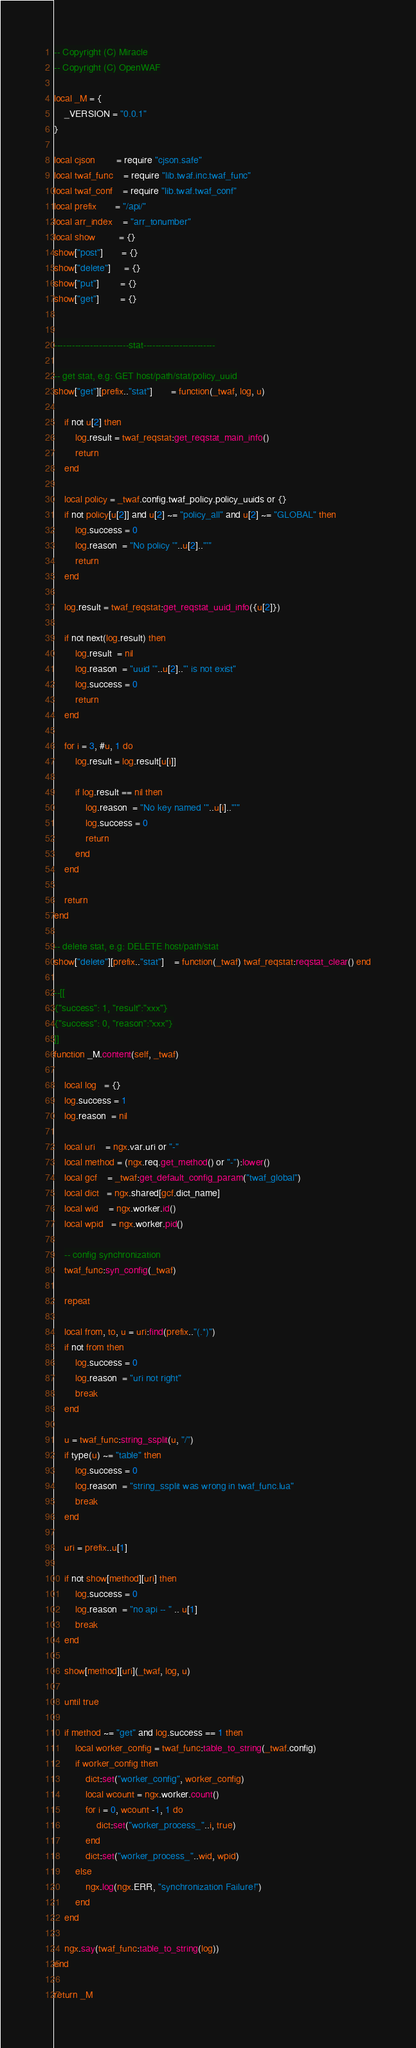<code> <loc_0><loc_0><loc_500><loc_500><_Lua_>
-- Copyright (C) Miracle
-- Copyright (C) OpenWAF

local _M = {
    _VERSION = "0.0.1"
}

local cjson        = require "cjson.safe"
local twaf_func    = require "lib.twaf.inc.twaf_func"
local twaf_conf    = require "lib.twaf.twaf_conf"
local prefix       = "/api/"
local arr_index    = "arr_tonumber"
local show         = {}
show["post"]       = {}
show["delete"]     = {}
show["put"]        = {}
show["get"]        = {}


-------------------------stat------------------------

-- get stat, e.g: GET host/path/stat/policy_uuid
show["get"][prefix.."stat"]       = function(_twaf, log, u)
    
    if not u[2] then
        log.result = twaf_reqstat:get_reqstat_main_info()
        return
    end
    
    local policy = _twaf.config.twaf_policy.policy_uuids or {}
    if not policy[u[2]] and u[2] ~= "policy_all" and u[2] ~= "GLOBAL" then
        log.success = 0
        log.reason  = "No policy '"..u[2].."'"
        return
    end
    
    log.result = twaf_reqstat:get_reqstat_uuid_info({u[2]})
    
    if not next(log.result) then
        log.result  = nil
        log.reason  = "uuid '"..u[2].."' is not exist"
        log.success = 0
        return
    end
    
    for i = 3, #u, 1 do
        log.result = log.result[u[i]]
        
        if log.result == nil then
            log.reason  = "No key named '"..u[i].."'"
            log.success = 0
            return
        end
    end
    
    return
end

-- delete stat, e.g: DELETE host/path/stat
show["delete"][prefix.."stat"]    = function(_twaf) twaf_reqstat:reqstat_clear() end

--[[
{"success": 1, "result":"xxx"}
{"success": 0, "reason":"xxx"}
]]
function _M.content(self, _twaf)

    local log   = {}
    log.success = 1
    log.reason  = nil
    
    local uri    = ngx.var.uri or "-"
    local method = (ngx.req.get_method() or "-"):lower()
    local gcf    = _twaf:get_default_config_param("twaf_global")
    local dict   = ngx.shared[gcf.dict_name]
    local wid    = ngx.worker.id()
    local wpid   = ngx.worker.pid()
    
    -- config synchronization
    twaf_func:syn_config(_twaf)
    
    repeat
    
    local from, to, u = uri:find(prefix.."(.*)")
    if not from then
        log.success = 0
        log.reason  = "uri not right"
        break
    end
    
    u = twaf_func:string_ssplit(u, "/")
    if type(u) ~= "table" then
        log.success = 0
        log.reason  = "string_ssplit was wrong in twaf_func.lua"
        break
    end
    
    uri = prefix..u[1]
    
    if not show[method][uri] then
        log.success = 0
        log.reason  = "no api -- " .. u[1]
        break
    end
    
    show[method][uri](_twaf, log, u)
    
    until true
    
    if method ~= "get" and log.success == 1 then
        local worker_config = twaf_func:table_to_string(_twaf.config)
        if worker_config then
            dict:set("worker_config", worker_config)
            local wcount = ngx.worker.count()
            for i = 0, wcount -1, 1 do
                dict:set("worker_process_"..i, true)
            end
            dict:set("worker_process_"..wid, wpid)
        else
            ngx.log(ngx.ERR, "synchronization Failure!")
        end
    end
    
    ngx.say(twaf_func:table_to_string(log))
end

return _M</code> 